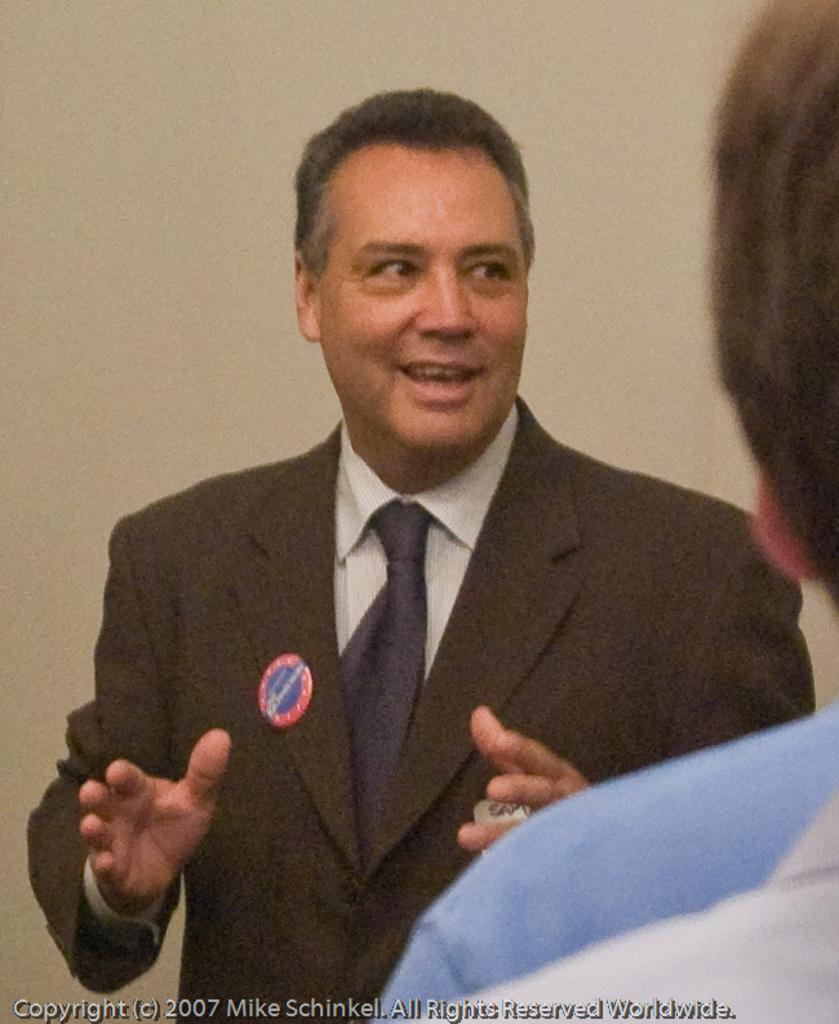What is the main subject of the image? There is a man standing in the image. Can you describe the man's attire? The man is wearing a suit. What can be seen in the background of the image? There is a wall visible in the background of the image, and another person's head is also visible. Where is the text located in the image? The text is at the left bottom of the image. What type of badge is the man wearing in the image? There is no badge visible in the image, so it cannot be determined if the man is wearing a badge or what type it might be. 